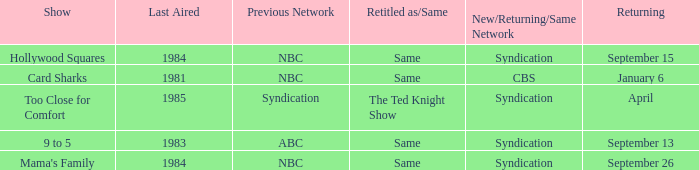What was the earliest aired show that's returning on September 13? 1983.0. 